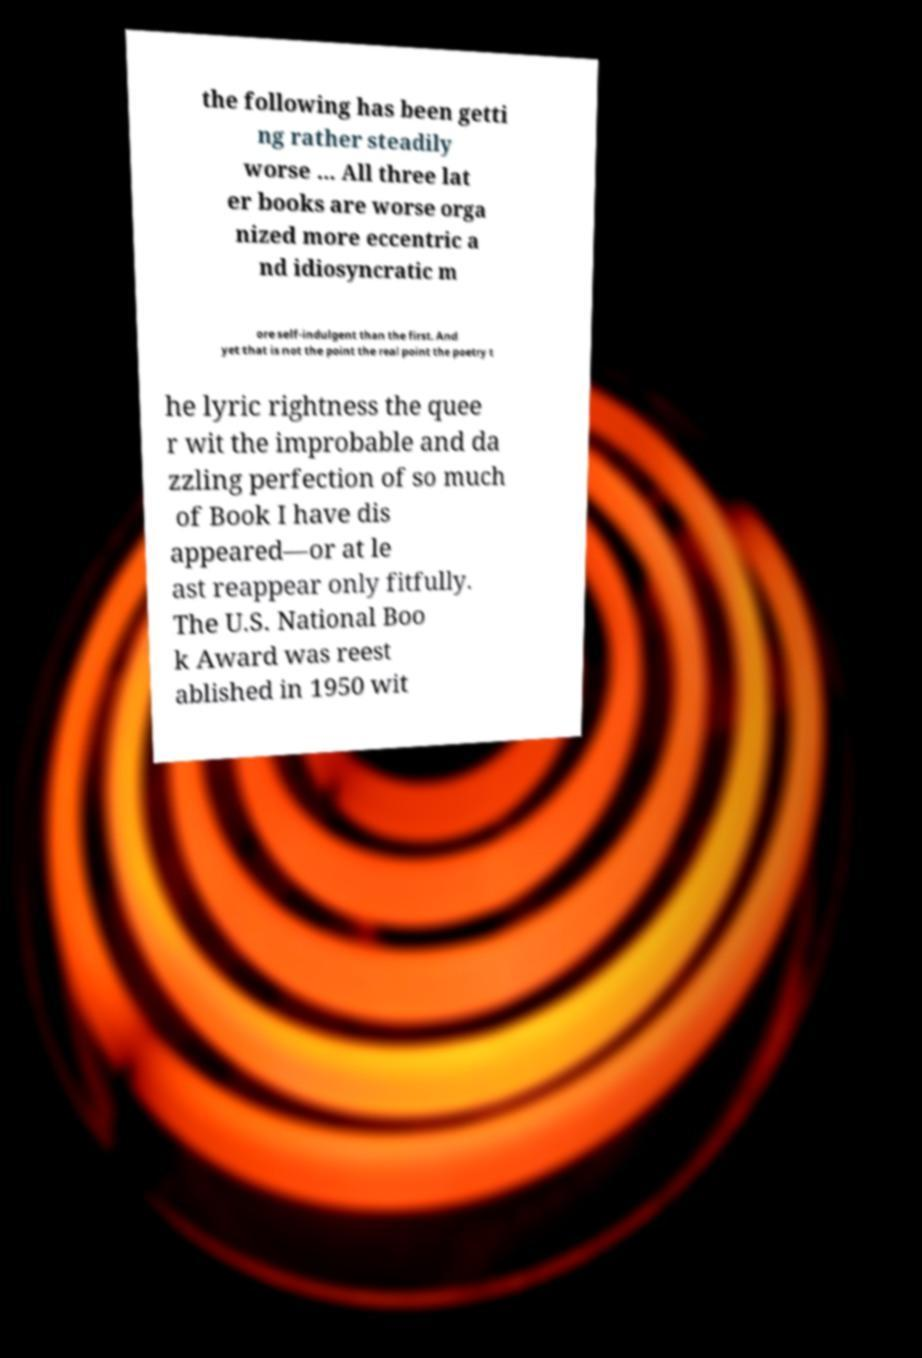Could you extract and type out the text from this image? the following has been getti ng rather steadily worse ... All three lat er books are worse orga nized more eccentric a nd idiosyncratic m ore self-indulgent than the first. And yet that is not the point the real point the poetry t he lyric rightness the quee r wit the improbable and da zzling perfection of so much of Book I have dis appeared—or at le ast reappear only fitfully. The U.S. National Boo k Award was reest ablished in 1950 wit 